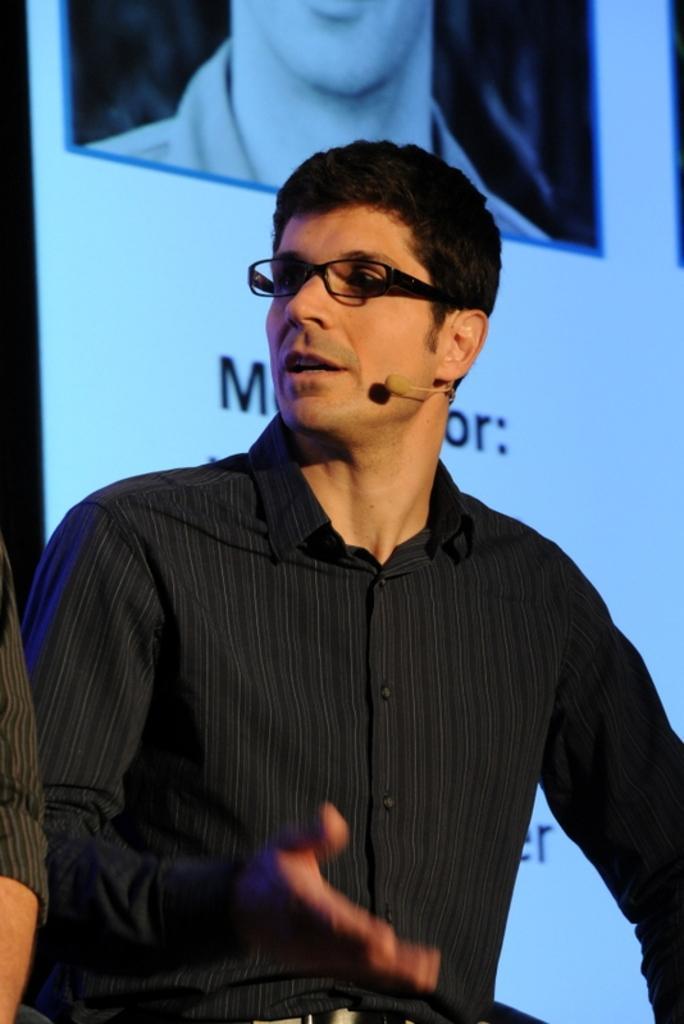Can you describe this image briefly? In this picture we can see a person in the shirt is explaining something and to the man there is a microphone and spectacles. Behind the man it looks like a screen and on the left side of the man there is a person hand. 